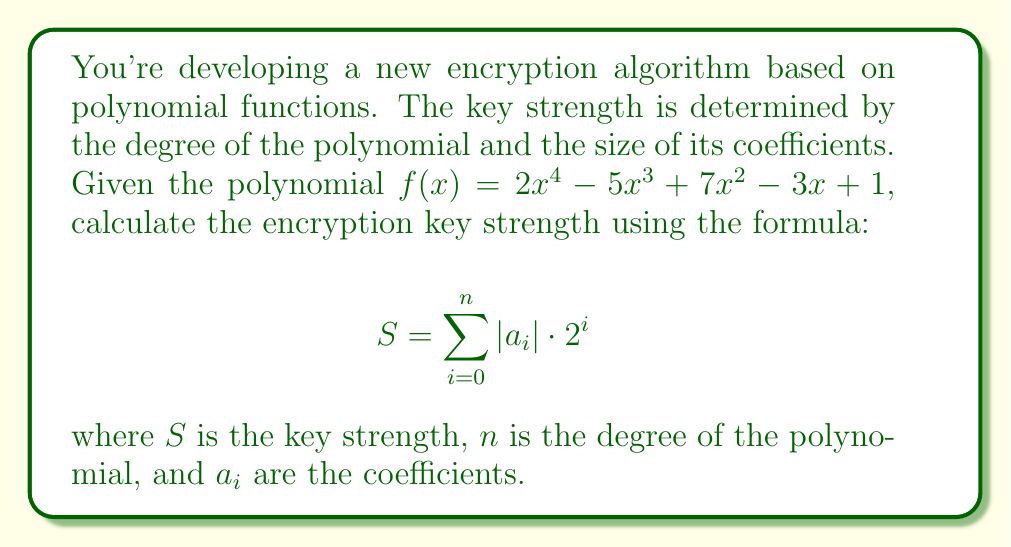Help me with this question. To solve this problem, we need to follow these steps:

1) Identify the degree of the polynomial and its coefficients:
   The polynomial is $f(x) = 2x^4 - 5x^3 + 7x^2 - 3x + 1$
   Degree $n = 4$
   Coefficients: $a_4 = 2$, $a_3 = -5$, $a_2 = 7$, $a_1 = -3$, $a_0 = 1$

2) Apply the formula $S = \sum_{i=0}^n |a_i| \cdot 2^i$:

   $S = |a_0| \cdot 2^0 + |a_1| \cdot 2^1 + |a_2| \cdot 2^2 + |a_3| \cdot 2^3 + |a_4| \cdot 2^4$

3) Substitute the values:

   $S = |1| \cdot 2^0 + |-3| \cdot 2^1 + |7| \cdot 2^2 + |-5| \cdot 2^3 + |2| \cdot 2^4$

4) Calculate each term:

   $S = 1 \cdot 1 + 3 \cdot 2 + 7 \cdot 4 + 5 \cdot 8 + 2 \cdot 16$
   $S = 1 + 6 + 28 + 40 + 32$

5) Sum up all terms:

   $S = 107$

Therefore, the encryption key strength is 107.
Answer: $S = 107$ 